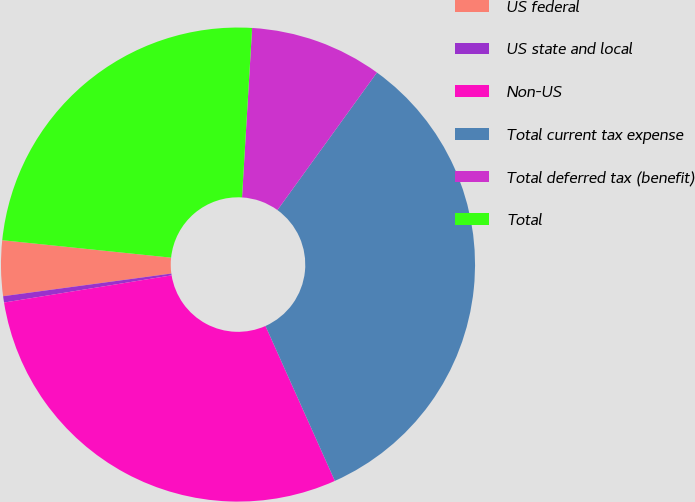<chart> <loc_0><loc_0><loc_500><loc_500><pie_chart><fcel>US federal<fcel>US state and local<fcel>Non-US<fcel>Total current tax expense<fcel>Total deferred tax (benefit)<fcel>Total<nl><fcel>3.77%<fcel>0.43%<fcel>29.14%<fcel>33.33%<fcel>9.02%<fcel>24.31%<nl></chart> 